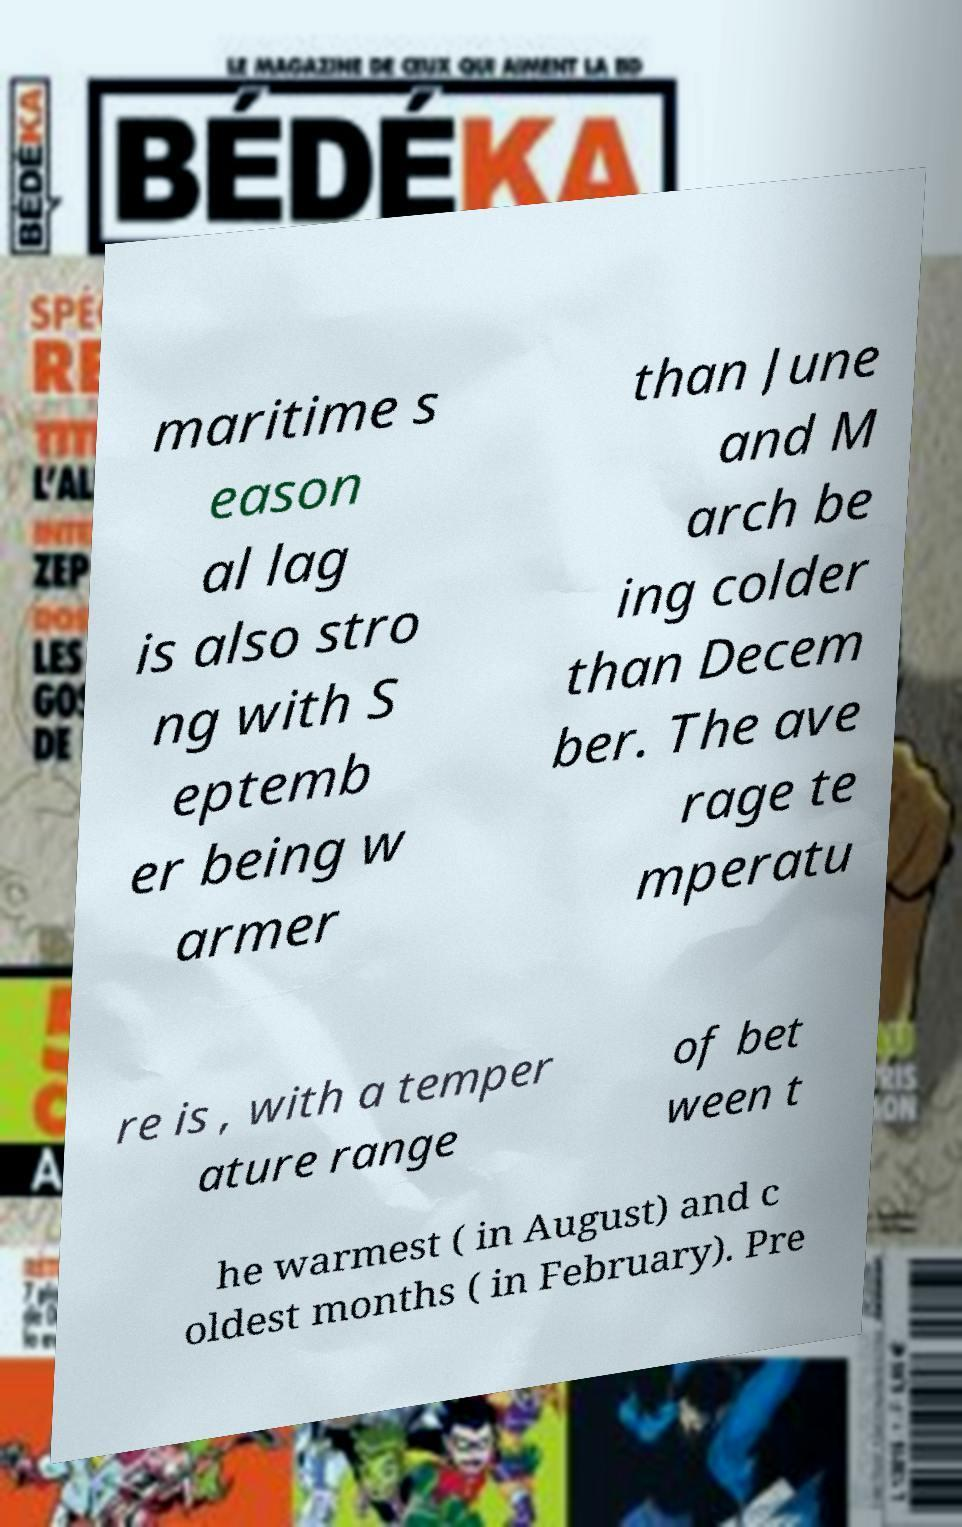Please identify and transcribe the text found in this image. maritime s eason al lag is also stro ng with S eptemb er being w armer than June and M arch be ing colder than Decem ber. The ave rage te mperatu re is , with a temper ature range of bet ween t he warmest ( in August) and c oldest months ( in February). Pre 